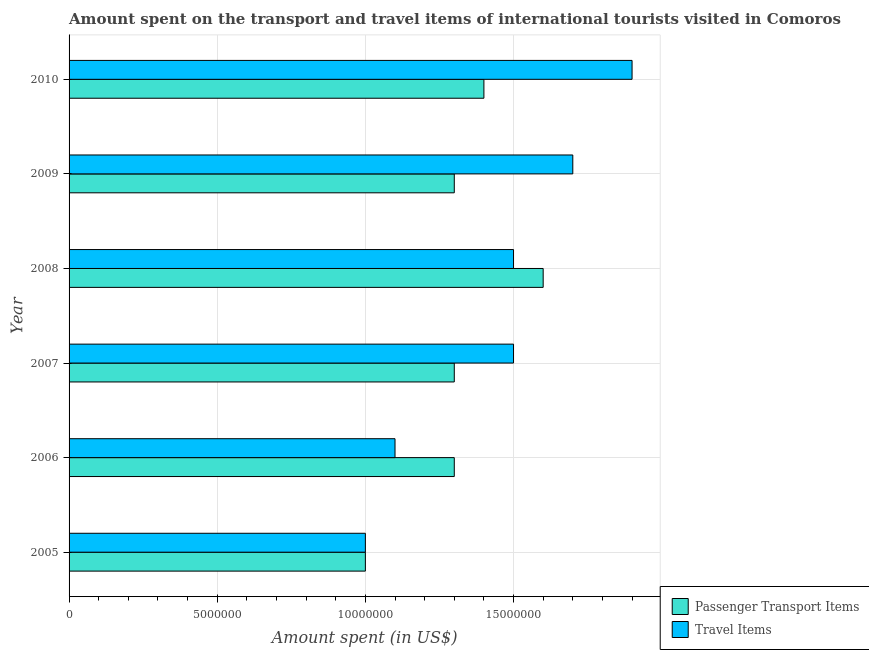How many groups of bars are there?
Your answer should be compact. 6. Are the number of bars per tick equal to the number of legend labels?
Provide a succinct answer. Yes. Are the number of bars on each tick of the Y-axis equal?
Provide a succinct answer. Yes. How many bars are there on the 4th tick from the bottom?
Your answer should be very brief. 2. What is the label of the 5th group of bars from the top?
Provide a succinct answer. 2006. What is the amount spent on passenger transport items in 2008?
Your answer should be very brief. 1.60e+07. Across all years, what is the maximum amount spent in travel items?
Offer a terse response. 1.90e+07. Across all years, what is the minimum amount spent in travel items?
Your answer should be compact. 1.00e+07. In which year was the amount spent in travel items minimum?
Make the answer very short. 2005. What is the total amount spent in travel items in the graph?
Keep it short and to the point. 8.70e+07. What is the difference between the amount spent on passenger transport items in 2008 and that in 2009?
Offer a very short reply. 3.00e+06. What is the difference between the amount spent on passenger transport items in 2005 and the amount spent in travel items in 2007?
Give a very brief answer. -5.00e+06. What is the average amount spent on passenger transport items per year?
Offer a very short reply. 1.32e+07. In the year 2007, what is the difference between the amount spent in travel items and amount spent on passenger transport items?
Your answer should be compact. 2.00e+06. What is the ratio of the amount spent on passenger transport items in 2007 to that in 2009?
Offer a very short reply. 1. Is the amount spent in travel items in 2005 less than that in 2006?
Give a very brief answer. Yes. What is the difference between the highest and the lowest amount spent in travel items?
Provide a succinct answer. 9.00e+06. In how many years, is the amount spent on passenger transport items greater than the average amount spent on passenger transport items taken over all years?
Make the answer very short. 2. What does the 2nd bar from the top in 2010 represents?
Your answer should be compact. Passenger Transport Items. What does the 2nd bar from the bottom in 2007 represents?
Offer a terse response. Travel Items. How many bars are there?
Provide a succinct answer. 12. How many years are there in the graph?
Your answer should be compact. 6. Are the values on the major ticks of X-axis written in scientific E-notation?
Provide a short and direct response. No. Does the graph contain any zero values?
Your answer should be very brief. No. Does the graph contain grids?
Keep it short and to the point. Yes. Where does the legend appear in the graph?
Your answer should be compact. Bottom right. How are the legend labels stacked?
Offer a terse response. Vertical. What is the title of the graph?
Offer a very short reply. Amount spent on the transport and travel items of international tourists visited in Comoros. What is the label or title of the X-axis?
Provide a succinct answer. Amount spent (in US$). What is the Amount spent (in US$) in Travel Items in 2005?
Your answer should be very brief. 1.00e+07. What is the Amount spent (in US$) of Passenger Transport Items in 2006?
Give a very brief answer. 1.30e+07. What is the Amount spent (in US$) of Travel Items in 2006?
Offer a terse response. 1.10e+07. What is the Amount spent (in US$) of Passenger Transport Items in 2007?
Your response must be concise. 1.30e+07. What is the Amount spent (in US$) in Travel Items in 2007?
Offer a very short reply. 1.50e+07. What is the Amount spent (in US$) of Passenger Transport Items in 2008?
Make the answer very short. 1.60e+07. What is the Amount spent (in US$) in Travel Items in 2008?
Offer a terse response. 1.50e+07. What is the Amount spent (in US$) in Passenger Transport Items in 2009?
Make the answer very short. 1.30e+07. What is the Amount spent (in US$) of Travel Items in 2009?
Your answer should be compact. 1.70e+07. What is the Amount spent (in US$) in Passenger Transport Items in 2010?
Offer a very short reply. 1.40e+07. What is the Amount spent (in US$) of Travel Items in 2010?
Give a very brief answer. 1.90e+07. Across all years, what is the maximum Amount spent (in US$) in Passenger Transport Items?
Your answer should be very brief. 1.60e+07. Across all years, what is the maximum Amount spent (in US$) in Travel Items?
Provide a short and direct response. 1.90e+07. Across all years, what is the minimum Amount spent (in US$) in Passenger Transport Items?
Your answer should be compact. 1.00e+07. Across all years, what is the minimum Amount spent (in US$) in Travel Items?
Offer a very short reply. 1.00e+07. What is the total Amount spent (in US$) in Passenger Transport Items in the graph?
Provide a short and direct response. 7.90e+07. What is the total Amount spent (in US$) in Travel Items in the graph?
Your response must be concise. 8.70e+07. What is the difference between the Amount spent (in US$) of Passenger Transport Items in 2005 and that in 2006?
Provide a short and direct response. -3.00e+06. What is the difference between the Amount spent (in US$) of Travel Items in 2005 and that in 2006?
Keep it short and to the point. -1.00e+06. What is the difference between the Amount spent (in US$) in Travel Items in 2005 and that in 2007?
Your answer should be compact. -5.00e+06. What is the difference between the Amount spent (in US$) in Passenger Transport Items in 2005 and that in 2008?
Keep it short and to the point. -6.00e+06. What is the difference between the Amount spent (in US$) of Travel Items in 2005 and that in 2008?
Offer a terse response. -5.00e+06. What is the difference between the Amount spent (in US$) in Travel Items in 2005 and that in 2009?
Ensure brevity in your answer.  -7.00e+06. What is the difference between the Amount spent (in US$) in Travel Items in 2005 and that in 2010?
Give a very brief answer. -9.00e+06. What is the difference between the Amount spent (in US$) in Passenger Transport Items in 2006 and that in 2007?
Provide a short and direct response. 0. What is the difference between the Amount spent (in US$) of Travel Items in 2006 and that in 2007?
Provide a short and direct response. -4.00e+06. What is the difference between the Amount spent (in US$) of Passenger Transport Items in 2006 and that in 2009?
Provide a succinct answer. 0. What is the difference between the Amount spent (in US$) in Travel Items in 2006 and that in 2009?
Offer a very short reply. -6.00e+06. What is the difference between the Amount spent (in US$) in Passenger Transport Items in 2006 and that in 2010?
Your response must be concise. -1.00e+06. What is the difference between the Amount spent (in US$) in Travel Items in 2006 and that in 2010?
Keep it short and to the point. -8.00e+06. What is the difference between the Amount spent (in US$) of Passenger Transport Items in 2007 and that in 2008?
Your response must be concise. -3.00e+06. What is the difference between the Amount spent (in US$) in Travel Items in 2007 and that in 2008?
Your answer should be very brief. 0. What is the difference between the Amount spent (in US$) in Travel Items in 2007 and that in 2009?
Ensure brevity in your answer.  -2.00e+06. What is the difference between the Amount spent (in US$) of Passenger Transport Items in 2007 and that in 2010?
Keep it short and to the point. -1.00e+06. What is the difference between the Amount spent (in US$) in Travel Items in 2007 and that in 2010?
Provide a succinct answer. -4.00e+06. What is the difference between the Amount spent (in US$) in Passenger Transport Items in 2008 and that in 2009?
Your answer should be very brief. 3.00e+06. What is the difference between the Amount spent (in US$) of Travel Items in 2008 and that in 2009?
Make the answer very short. -2.00e+06. What is the difference between the Amount spent (in US$) of Travel Items in 2009 and that in 2010?
Offer a very short reply. -2.00e+06. What is the difference between the Amount spent (in US$) in Passenger Transport Items in 2005 and the Amount spent (in US$) in Travel Items in 2006?
Make the answer very short. -1.00e+06. What is the difference between the Amount spent (in US$) in Passenger Transport Items in 2005 and the Amount spent (in US$) in Travel Items in 2007?
Your answer should be very brief. -5.00e+06. What is the difference between the Amount spent (in US$) in Passenger Transport Items in 2005 and the Amount spent (in US$) in Travel Items in 2008?
Make the answer very short. -5.00e+06. What is the difference between the Amount spent (in US$) of Passenger Transport Items in 2005 and the Amount spent (in US$) of Travel Items in 2009?
Provide a short and direct response. -7.00e+06. What is the difference between the Amount spent (in US$) in Passenger Transport Items in 2005 and the Amount spent (in US$) in Travel Items in 2010?
Offer a very short reply. -9.00e+06. What is the difference between the Amount spent (in US$) of Passenger Transport Items in 2006 and the Amount spent (in US$) of Travel Items in 2008?
Your response must be concise. -2.00e+06. What is the difference between the Amount spent (in US$) of Passenger Transport Items in 2006 and the Amount spent (in US$) of Travel Items in 2009?
Keep it short and to the point. -4.00e+06. What is the difference between the Amount spent (in US$) in Passenger Transport Items in 2006 and the Amount spent (in US$) in Travel Items in 2010?
Keep it short and to the point. -6.00e+06. What is the difference between the Amount spent (in US$) in Passenger Transport Items in 2007 and the Amount spent (in US$) in Travel Items in 2008?
Provide a succinct answer. -2.00e+06. What is the difference between the Amount spent (in US$) of Passenger Transport Items in 2007 and the Amount spent (in US$) of Travel Items in 2010?
Provide a short and direct response. -6.00e+06. What is the difference between the Amount spent (in US$) in Passenger Transport Items in 2009 and the Amount spent (in US$) in Travel Items in 2010?
Your answer should be very brief. -6.00e+06. What is the average Amount spent (in US$) in Passenger Transport Items per year?
Offer a terse response. 1.32e+07. What is the average Amount spent (in US$) in Travel Items per year?
Your answer should be very brief. 1.45e+07. In the year 2006, what is the difference between the Amount spent (in US$) of Passenger Transport Items and Amount spent (in US$) of Travel Items?
Your answer should be very brief. 2.00e+06. In the year 2007, what is the difference between the Amount spent (in US$) of Passenger Transport Items and Amount spent (in US$) of Travel Items?
Make the answer very short. -2.00e+06. In the year 2008, what is the difference between the Amount spent (in US$) of Passenger Transport Items and Amount spent (in US$) of Travel Items?
Ensure brevity in your answer.  1.00e+06. In the year 2009, what is the difference between the Amount spent (in US$) in Passenger Transport Items and Amount spent (in US$) in Travel Items?
Offer a very short reply. -4.00e+06. In the year 2010, what is the difference between the Amount spent (in US$) in Passenger Transport Items and Amount spent (in US$) in Travel Items?
Keep it short and to the point. -5.00e+06. What is the ratio of the Amount spent (in US$) in Passenger Transport Items in 2005 to that in 2006?
Your answer should be very brief. 0.77. What is the ratio of the Amount spent (in US$) of Travel Items in 2005 to that in 2006?
Your answer should be very brief. 0.91. What is the ratio of the Amount spent (in US$) of Passenger Transport Items in 2005 to that in 2007?
Your response must be concise. 0.77. What is the ratio of the Amount spent (in US$) of Travel Items in 2005 to that in 2007?
Your answer should be compact. 0.67. What is the ratio of the Amount spent (in US$) in Passenger Transport Items in 2005 to that in 2009?
Ensure brevity in your answer.  0.77. What is the ratio of the Amount spent (in US$) in Travel Items in 2005 to that in 2009?
Offer a terse response. 0.59. What is the ratio of the Amount spent (in US$) of Travel Items in 2005 to that in 2010?
Your answer should be very brief. 0.53. What is the ratio of the Amount spent (in US$) of Passenger Transport Items in 2006 to that in 2007?
Offer a terse response. 1. What is the ratio of the Amount spent (in US$) of Travel Items in 2006 to that in 2007?
Provide a short and direct response. 0.73. What is the ratio of the Amount spent (in US$) of Passenger Transport Items in 2006 to that in 2008?
Offer a very short reply. 0.81. What is the ratio of the Amount spent (in US$) of Travel Items in 2006 to that in 2008?
Provide a succinct answer. 0.73. What is the ratio of the Amount spent (in US$) in Passenger Transport Items in 2006 to that in 2009?
Provide a succinct answer. 1. What is the ratio of the Amount spent (in US$) of Travel Items in 2006 to that in 2009?
Provide a short and direct response. 0.65. What is the ratio of the Amount spent (in US$) in Travel Items in 2006 to that in 2010?
Your answer should be very brief. 0.58. What is the ratio of the Amount spent (in US$) of Passenger Transport Items in 2007 to that in 2008?
Your response must be concise. 0.81. What is the ratio of the Amount spent (in US$) of Travel Items in 2007 to that in 2008?
Offer a very short reply. 1. What is the ratio of the Amount spent (in US$) in Travel Items in 2007 to that in 2009?
Keep it short and to the point. 0.88. What is the ratio of the Amount spent (in US$) of Passenger Transport Items in 2007 to that in 2010?
Keep it short and to the point. 0.93. What is the ratio of the Amount spent (in US$) in Travel Items in 2007 to that in 2010?
Offer a very short reply. 0.79. What is the ratio of the Amount spent (in US$) of Passenger Transport Items in 2008 to that in 2009?
Ensure brevity in your answer.  1.23. What is the ratio of the Amount spent (in US$) in Travel Items in 2008 to that in 2009?
Make the answer very short. 0.88. What is the ratio of the Amount spent (in US$) of Passenger Transport Items in 2008 to that in 2010?
Offer a terse response. 1.14. What is the ratio of the Amount spent (in US$) in Travel Items in 2008 to that in 2010?
Ensure brevity in your answer.  0.79. What is the ratio of the Amount spent (in US$) in Passenger Transport Items in 2009 to that in 2010?
Offer a very short reply. 0.93. What is the ratio of the Amount spent (in US$) of Travel Items in 2009 to that in 2010?
Your response must be concise. 0.89. What is the difference between the highest and the second highest Amount spent (in US$) of Passenger Transport Items?
Offer a very short reply. 2.00e+06. What is the difference between the highest and the second highest Amount spent (in US$) of Travel Items?
Offer a terse response. 2.00e+06. What is the difference between the highest and the lowest Amount spent (in US$) in Passenger Transport Items?
Give a very brief answer. 6.00e+06. What is the difference between the highest and the lowest Amount spent (in US$) of Travel Items?
Give a very brief answer. 9.00e+06. 